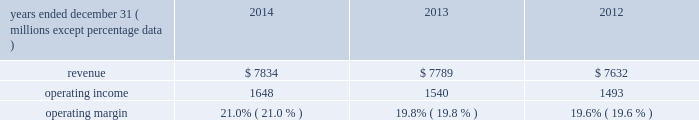Equity equity at december 31 , 2014 was $ 6.6 billion , a decrease of $ 1.6 billion from december 31 , 2013 .
The decrease resulted primarily due to share repurchases of $ 2.3 billion , $ 273 million of dividends to shareholders , and an increase in accumulated other comprehensive loss of $ 760 million , partially offset by net income of $ 1.4 billion .
The $ 760 million increase in accumulated other comprehensive loss from december 31 , 2013 , primarily reflects the following : 2022 negative net foreign currency translation adjustments of $ 504 million , which are attributable to the strengthening of the u.s .
Dollar against certain foreign currencies , 2022 an increase of $ 260 million in net post-retirement benefit obligations , 2022 net derivative gains of $ 5 million , and 2022 net investment losses of $ 1 million .
Review by segment general we serve clients through the following segments : 2022 risk solutions acts as an advisor and insurance and reinsurance broker , helping clients manage their risks , via consultation , as well as negotiation and placement of insurance risk with insurance carriers through our global distribution network .
2022 hr solutions partners with organizations to solve their most complex benefits , talent and related financial challenges , and improve business performance by designing , implementing , communicating and administering a wide range of human capital , retirement , investment management , health care , compensation and talent management strategies .
Risk solutions .
The demand for property and casualty insurance generally rises as the overall level of economic activity increases and generally falls as such activity decreases , affecting both the commissions and fees generated by our brokerage business .
The economic activity that impacts property and casualty insurance is described as exposure units , and is most closely correlated with employment levels , corporate revenue and asset values .
During 2014 , pricing was flat on average globally , and we would still consider this to be a "soft market." in a soft market , premium rates flatten or decrease , along with commission revenues , due to increased competition for market share among insurance carriers or increased underwriting capacity .
Changes in premiums have a direct and potentially material impact on the insurance brokerage industry , as commission revenues are generally based on a percentage of the premiums paid by insureds .
Additionally , continuing through 2014 , we faced difficult conditions as a result of continued weakness in the global economy , the repricing of credit risk and the deterioration of the financial markets .
Weak economic conditions in many markets around the globe have reduced our customers' demand for our retail brokerage and reinsurance brokerage products , which have had a negative impact on our operational results .
Risk solutions generated approximately 65% ( 65 % ) of our consolidated total revenues in 2014 .
Revenues are generated primarily through fees paid by clients , commissions and fees paid by insurance and reinsurance companies , and investment income on funds held on behalf of clients .
Our revenues vary from quarter to quarter throughout the year as a result of the timing of our clients' policy renewals , the net effect of new and lost business , the timing of services provided to our clients , and the income we earn on investments , which is heavily influenced by short-term interest rates .
We operate in a highly competitive industry and compete with many retail insurance brokerage and agency firms , as well as with individual brokers , agents , and direct writers of insurance coverage .
Specifically , we address the highly specialized .
What is the difference between the average and the 2014's operating margin? 
Rationale: it is the variation between those values .
Computations: subtract(21.0%, table_average(operating margin, none))
Answer: 0.00867. 